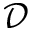<formula> <loc_0><loc_0><loc_500><loc_500>\mathcal { D }</formula> 